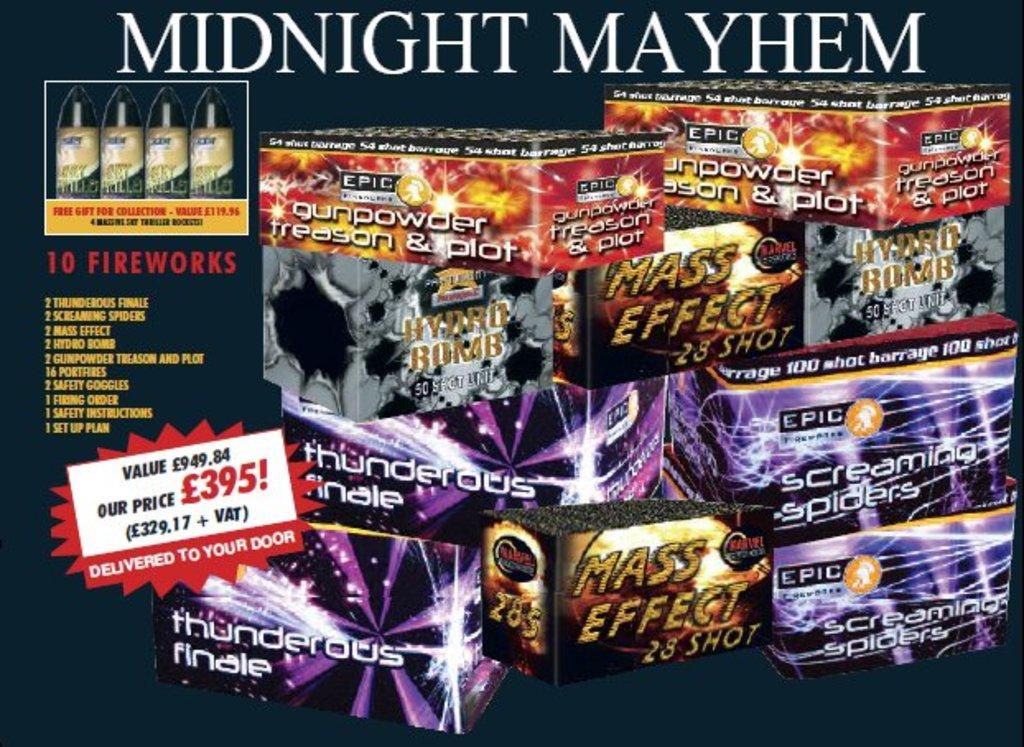Provide a one-sentence caption for the provided image. Boxes full of fireworks from the company Mindnight Mayhem. 